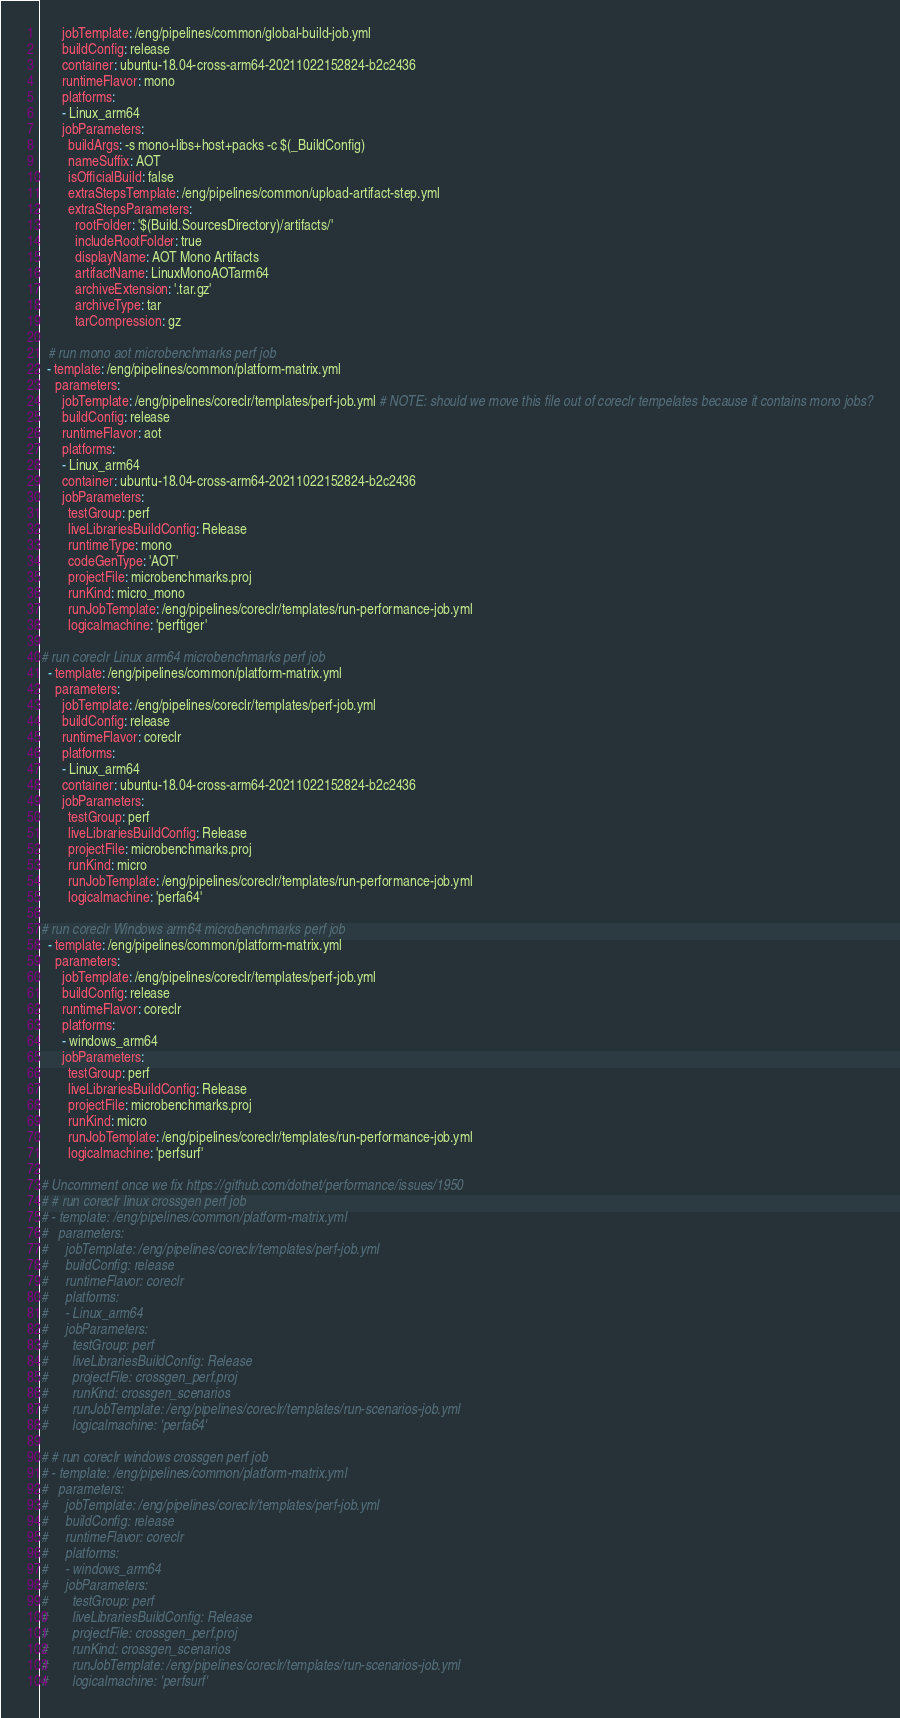<code> <loc_0><loc_0><loc_500><loc_500><_YAML_>      jobTemplate: /eng/pipelines/common/global-build-job.yml
      buildConfig: release
      container: ubuntu-18.04-cross-arm64-20211022152824-b2c2436
      runtimeFlavor: mono
      platforms:
      - Linux_arm64
      jobParameters:
        buildArgs: -s mono+libs+host+packs -c $(_BuildConfig)
        nameSuffix: AOT
        isOfficialBuild: false
        extraStepsTemplate: /eng/pipelines/common/upload-artifact-step.yml
        extraStepsParameters:
          rootFolder: '$(Build.SourcesDirectory)/artifacts/'
          includeRootFolder: true
          displayName: AOT Mono Artifacts
          artifactName: LinuxMonoAOTarm64
          archiveExtension: '.tar.gz'
          archiveType: tar
          tarCompression: gz

  # run mono aot microbenchmarks perf job
  - template: /eng/pipelines/common/platform-matrix.yml
    parameters:
      jobTemplate: /eng/pipelines/coreclr/templates/perf-job.yml # NOTE: should we move this file out of coreclr tempelates because it contains mono jobs?
      buildConfig: release
      runtimeFlavor: aot
      platforms:
      - Linux_arm64
      container: ubuntu-18.04-cross-arm64-20211022152824-b2c2436
      jobParameters:
        testGroup: perf
        liveLibrariesBuildConfig: Release
        runtimeType: mono
        codeGenType: 'AOT'
        projectFile: microbenchmarks.proj
        runKind: micro_mono
        runJobTemplate: /eng/pipelines/coreclr/templates/run-performance-job.yml
        logicalmachine: 'perftiger'

# run coreclr Linux arm64 microbenchmarks perf job
  - template: /eng/pipelines/common/platform-matrix.yml
    parameters:
      jobTemplate: /eng/pipelines/coreclr/templates/perf-job.yml
      buildConfig: release
      runtimeFlavor: coreclr
      platforms:
      - Linux_arm64
      container: ubuntu-18.04-cross-arm64-20211022152824-b2c2436
      jobParameters:
        testGroup: perf
        liveLibrariesBuildConfig: Release
        projectFile: microbenchmarks.proj
        runKind: micro
        runJobTemplate: /eng/pipelines/coreclr/templates/run-performance-job.yml
        logicalmachine: 'perfa64'

# run coreclr Windows arm64 microbenchmarks perf job
  - template: /eng/pipelines/common/platform-matrix.yml
    parameters:
      jobTemplate: /eng/pipelines/coreclr/templates/perf-job.yml
      buildConfig: release
      runtimeFlavor: coreclr
      platforms:
      - windows_arm64
      jobParameters:
        testGroup: perf
        liveLibrariesBuildConfig: Release
        projectFile: microbenchmarks.proj
        runKind: micro
        runJobTemplate: /eng/pipelines/coreclr/templates/run-performance-job.yml
        logicalmachine: 'perfsurf' 

# Uncomment once we fix https://github.com/dotnet/performance/issues/1950
# # run coreclr linux crossgen perf job
# - template: /eng/pipelines/common/platform-matrix.yml
#   parameters:
#     jobTemplate: /eng/pipelines/coreclr/templates/perf-job.yml
#     buildConfig: release
#     runtimeFlavor: coreclr
#     platforms:
#     - Linux_arm64
#     jobParameters:
#       testGroup: perf
#       liveLibrariesBuildConfig: Release
#       projectFile: crossgen_perf.proj
#       runKind: crossgen_scenarios
#       runJobTemplate: /eng/pipelines/coreclr/templates/run-scenarios-job.yml
#       logicalmachine: 'perfa64'

# # run coreclr windows crossgen perf job
# - template: /eng/pipelines/common/platform-matrix.yml
#   parameters:
#     jobTemplate: /eng/pipelines/coreclr/templates/perf-job.yml
#     buildConfig: release
#     runtimeFlavor: coreclr
#     platforms:
#     - windows_arm64
#     jobParameters:
#       testGroup: perf
#       liveLibrariesBuildConfig: Release
#       projectFile: crossgen_perf.proj
#       runKind: crossgen_scenarios
#       runJobTemplate: /eng/pipelines/coreclr/templates/run-scenarios-job.yml
#       logicalmachine: 'perfsurf'</code> 